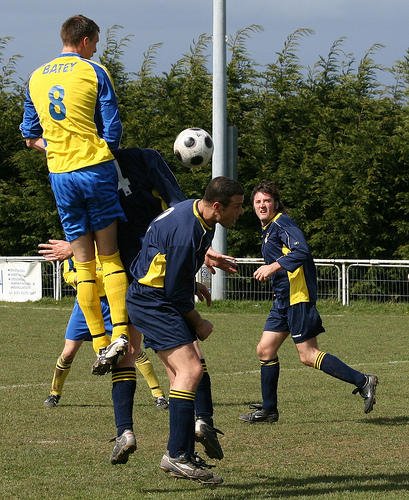<image>
Is the ball behind the pole? No. The ball is not behind the pole. From this viewpoint, the ball appears to be positioned elsewhere in the scene. Is there a ball in front of the man? Yes. The ball is positioned in front of the man, appearing closer to the camera viewpoint. Where is the soccer player in relation to the soccer player? Is it above the soccer player? No. The soccer player is not positioned above the soccer player. The vertical arrangement shows a different relationship. 